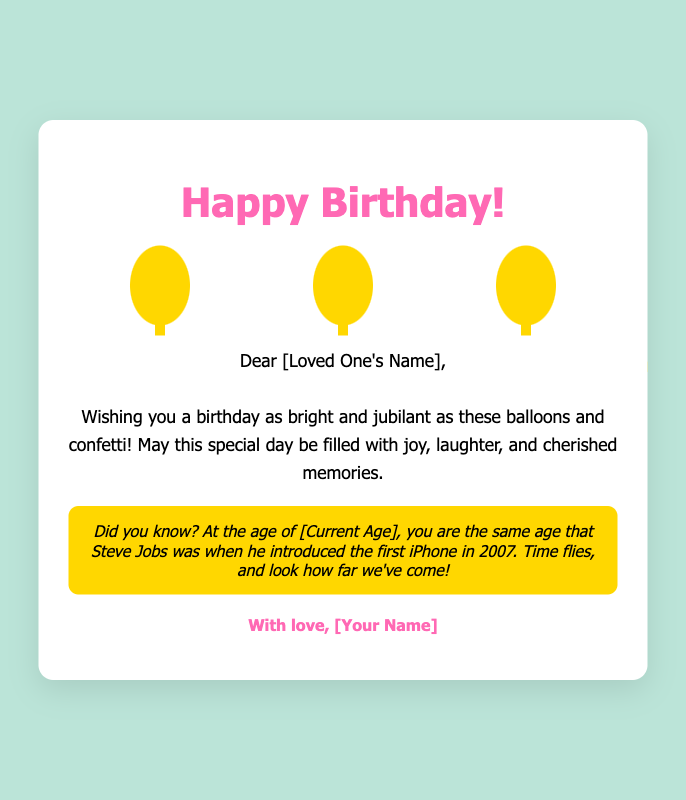What is the title of the card? The title is prominently displayed at the top of the card.
Answer: Happy Birthday! Who is the card addressed to? The card includes a personalized greeting, addressing a loved one.
Answer: [Loved One's Name] What color are the balloons? The balloons are illustrated in a specific color, which is integral to the design.
Answer: Gold What is the fun fact mentioned in the card? The fun fact relates to the recipient's current age compared to a historical figure's age.
Answer: At the age of [Current Age], you are the same age that Steve Jobs was when he introduced the first iPhone in 2007 What type of decoration is included on the card? The card features various decorative elements to enhance its festive appeal.
Answer: Balloons and confetti What emotion is conveyed in the message? The message aims to evoke a specific emotional response during a special occasion.
Answer: Joy How many pieces of confetti are generated? The total number of confetti pieces is predefined in the code for visual effect.
Answer: 100 